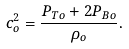Convert formula to latex. <formula><loc_0><loc_0><loc_500><loc_500>c _ { o } ^ { 2 } = \frac { P _ { T o } + 2 P _ { B o } } { \rho _ { o } } .</formula> 